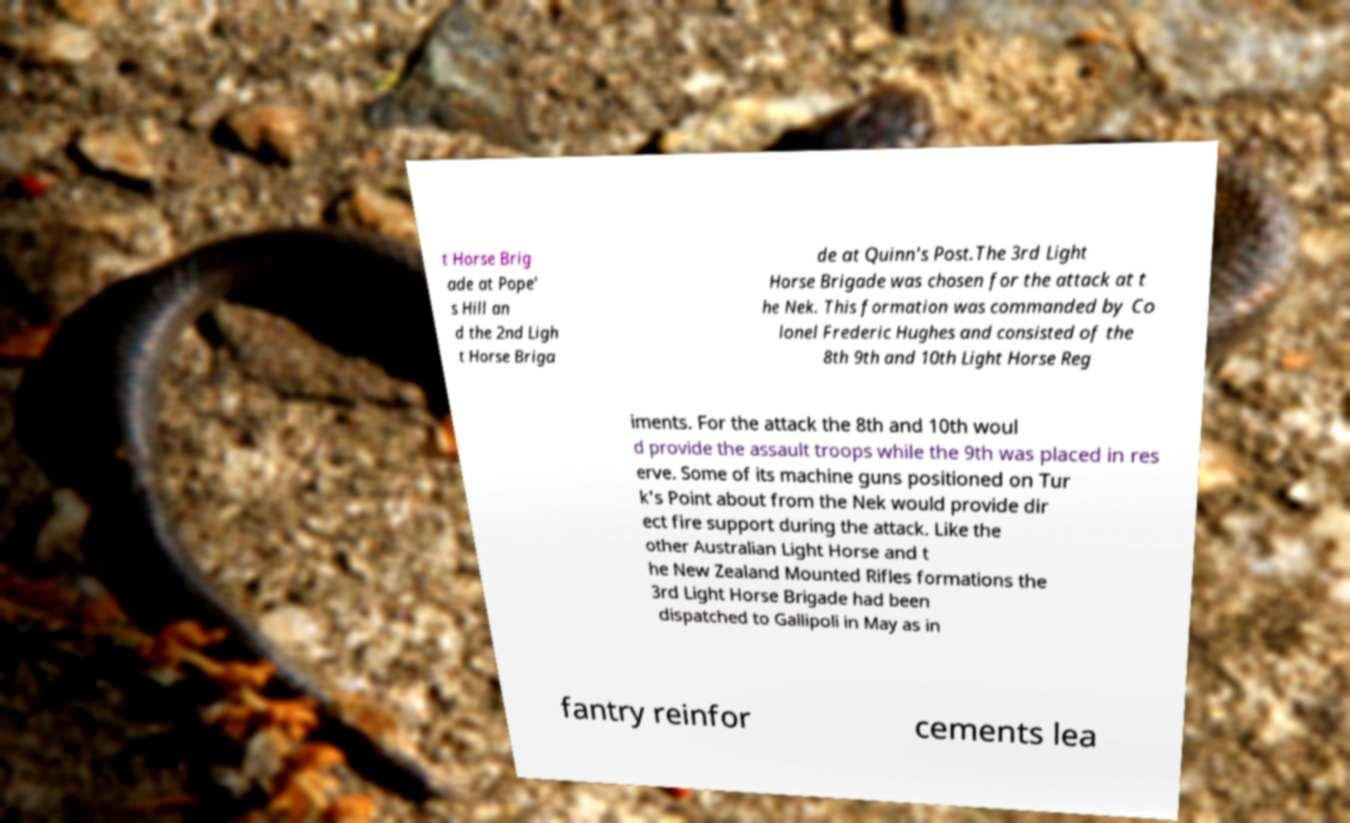Can you accurately transcribe the text from the provided image for me? t Horse Brig ade at Pope' s Hill an d the 2nd Ligh t Horse Briga de at Quinn's Post.The 3rd Light Horse Brigade was chosen for the attack at t he Nek. This formation was commanded by Co lonel Frederic Hughes and consisted of the 8th 9th and 10th Light Horse Reg iments. For the attack the 8th and 10th woul d provide the assault troops while the 9th was placed in res erve. Some of its machine guns positioned on Tur k's Point about from the Nek would provide dir ect fire support during the attack. Like the other Australian Light Horse and t he New Zealand Mounted Rifles formations the 3rd Light Horse Brigade had been dispatched to Gallipoli in May as in fantry reinfor cements lea 